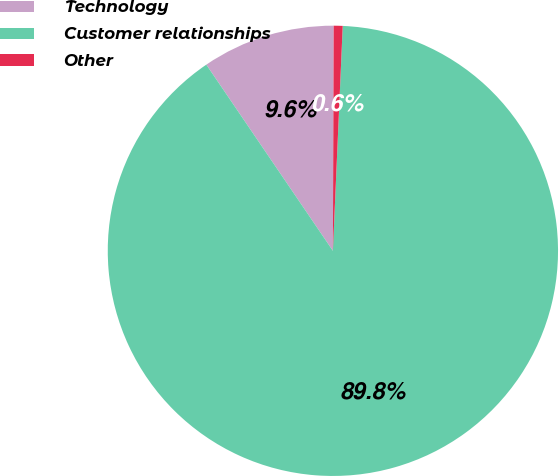<chart> <loc_0><loc_0><loc_500><loc_500><pie_chart><fcel>Technology<fcel>Customer relationships<fcel>Other<nl><fcel>9.56%<fcel>89.8%<fcel>0.64%<nl></chart> 